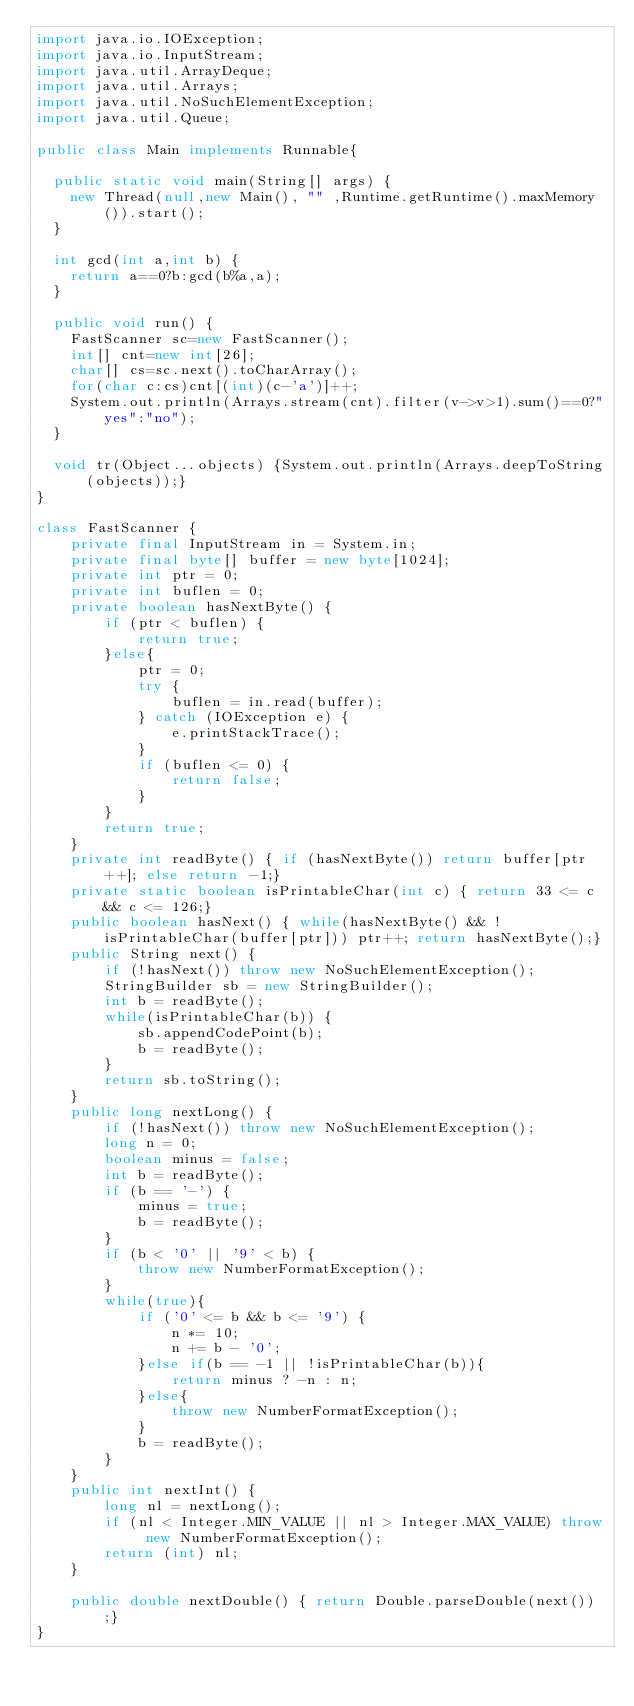<code> <loc_0><loc_0><loc_500><loc_500><_Java_>import java.io.IOException;
import java.io.InputStream;
import java.util.ArrayDeque;
import java.util.Arrays;
import java.util.NoSuchElementException;
import java.util.Queue;

public class Main implements Runnable{

	public static void main(String[] args) {
		new Thread(null,new Main(), "" ,Runtime.getRuntime().maxMemory()).start();
	}
	
	int gcd(int a,int b) {
		return a==0?b:gcd(b%a,a);
	}
	
	public void run() {
		FastScanner sc=new FastScanner();
		int[] cnt=new int[26];
		char[] cs=sc.next().toCharArray();
		for(char c:cs)cnt[(int)(c-'a')]++;
		System.out.println(Arrays.stream(cnt).filter(v->v>1).sum()==0?"yes":"no");
	}
	
	void tr(Object...objects) {System.out.println(Arrays.deepToString(objects));}
}

class FastScanner {
    private final InputStream in = System.in;
    private final byte[] buffer = new byte[1024];
    private int ptr = 0;
    private int buflen = 0;
    private boolean hasNextByte() {
        if (ptr < buflen) {
            return true;
        }else{
            ptr = 0;
            try {
                buflen = in.read(buffer);
            } catch (IOException e) {
                e.printStackTrace();
            }
            if (buflen <= 0) {
                return false;
            }
        }
        return true;
    }
    private int readByte() { if (hasNextByte()) return buffer[ptr++]; else return -1;}
    private static boolean isPrintableChar(int c) { return 33 <= c && c <= 126;}
    public boolean hasNext() { while(hasNextByte() && !isPrintableChar(buffer[ptr])) ptr++; return hasNextByte();}
    public String next() {
        if (!hasNext()) throw new NoSuchElementException();
        StringBuilder sb = new StringBuilder();
        int b = readByte();
        while(isPrintableChar(b)) {
            sb.appendCodePoint(b);
            b = readByte();
        }
        return sb.toString();
    }
    public long nextLong() {
        if (!hasNext()) throw new NoSuchElementException();
        long n = 0;
        boolean minus = false;
        int b = readByte();
        if (b == '-') {
            minus = true;
            b = readByte();
        }
        if (b < '0' || '9' < b) {
            throw new NumberFormatException();
        }
        while(true){
            if ('0' <= b && b <= '9') {
                n *= 10;
                n += b - '0';
            }else if(b == -1 || !isPrintableChar(b)){
                return minus ? -n : n;
            }else{
                throw new NumberFormatException();
            }
            b = readByte();
        }
    }
    public int nextInt() {
        long nl = nextLong();
        if (nl < Integer.MIN_VALUE || nl > Integer.MAX_VALUE) throw new NumberFormatException();
        return (int) nl;
    }
    
    public double nextDouble() { return Double.parseDouble(next());}
}</code> 